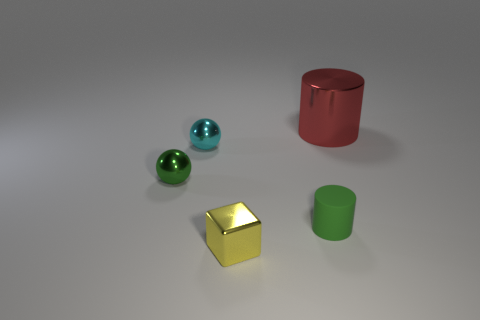Subtract all red cylinders. How many cylinders are left? 1 Subtract all cubes. How many objects are left? 4 Subtract 1 spheres. How many spheres are left? 1 Add 3 big red metallic objects. How many objects exist? 8 Subtract all metallic blocks. Subtract all rubber objects. How many objects are left? 3 Add 5 small objects. How many small objects are left? 9 Add 4 tiny cyan cylinders. How many tiny cyan cylinders exist? 4 Subtract 0 gray cylinders. How many objects are left? 5 Subtract all yellow balls. Subtract all cyan cubes. How many balls are left? 2 Subtract all red cylinders. How many green balls are left? 1 